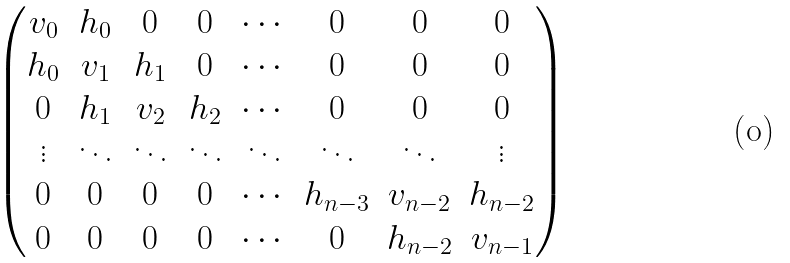Convert formula to latex. <formula><loc_0><loc_0><loc_500><loc_500>\begin{pmatrix} v _ { 0 } & h _ { 0 } & 0 & 0 & \cdots & 0 & 0 & 0 \\ h _ { 0 } & v _ { 1 } & h _ { 1 } & 0 & \cdots & 0 & 0 & 0 \\ 0 & h _ { 1 } & v _ { 2 } & h _ { 2 } & \cdots & 0 & 0 & 0 \\ \vdots & \ddots & \ddots & \ddots & \ddots & \ddots & \ddots & \vdots \\ 0 & 0 & 0 & 0 & \cdots & h _ { n - 3 } & v _ { n - 2 } & h _ { n - 2 } \\ 0 & 0 & 0 & 0 & \cdots & 0 & h _ { n - 2 } & v _ { n - 1 } \end{pmatrix}</formula> 